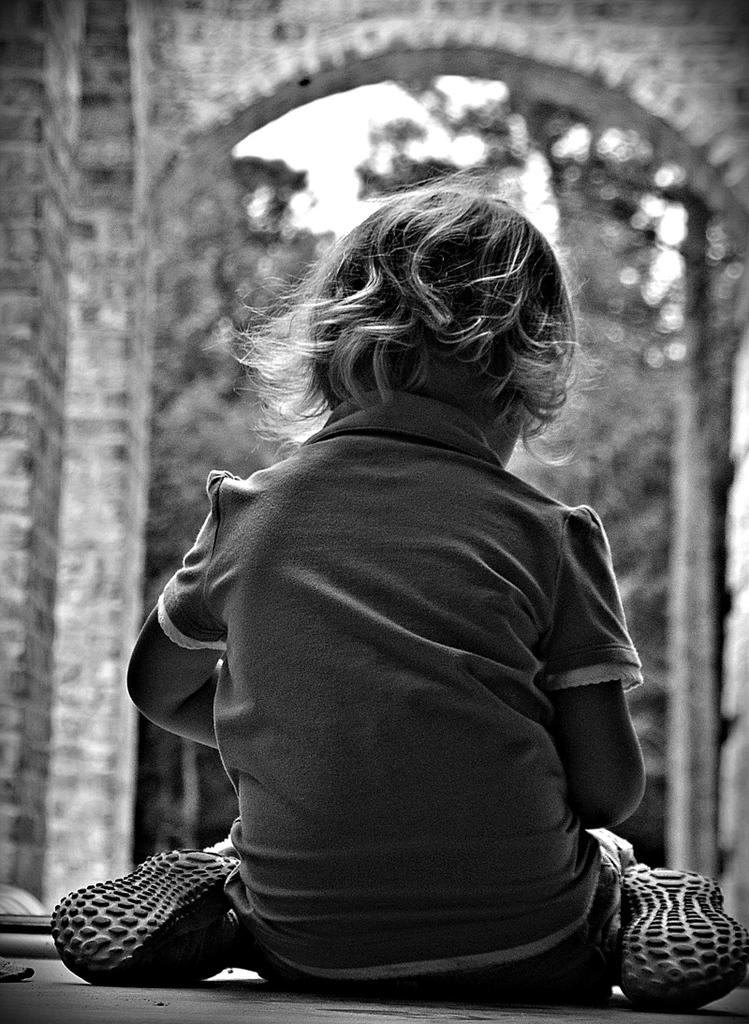What is the main subject of the image? The main subject of the image is a baby sitting on the floor. What is in front of the baby? There is an arch in front of the baby. What is the color scheme of the image? The image is in black and white. How many eyes does the baby have on the page? The image does not show the baby's eyes, and there is no page present in the image. 